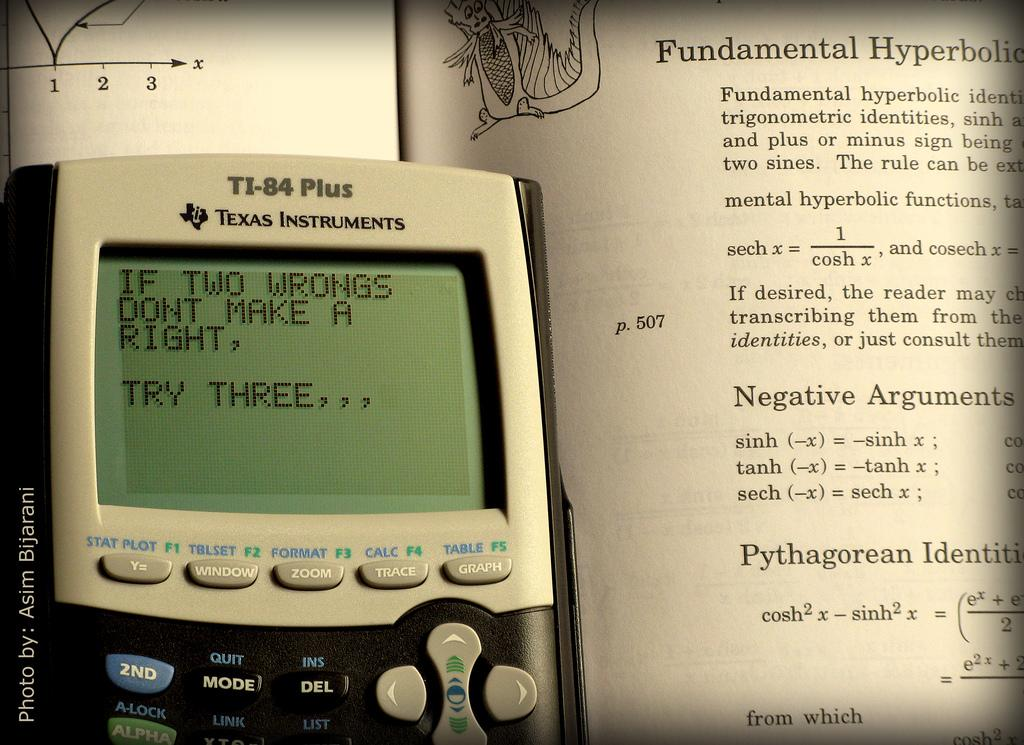<image>
Write a terse but informative summary of the picture. A T1-84 Plus device shows a message typed on the little screen. 